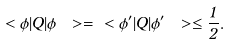Convert formula to latex. <formula><loc_0><loc_0><loc_500><loc_500>\ < \phi | Q | \phi \ > = \ < \phi ^ { \prime } | Q | \phi ^ { \prime } \ > \leq \frac { 1 } { 2 } .</formula> 